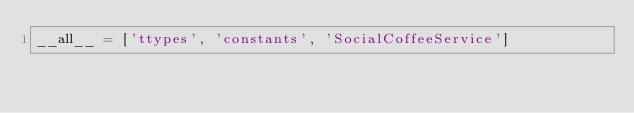<code> <loc_0><loc_0><loc_500><loc_500><_Python_>__all__ = ['ttypes', 'constants', 'SocialCoffeeService']
</code> 